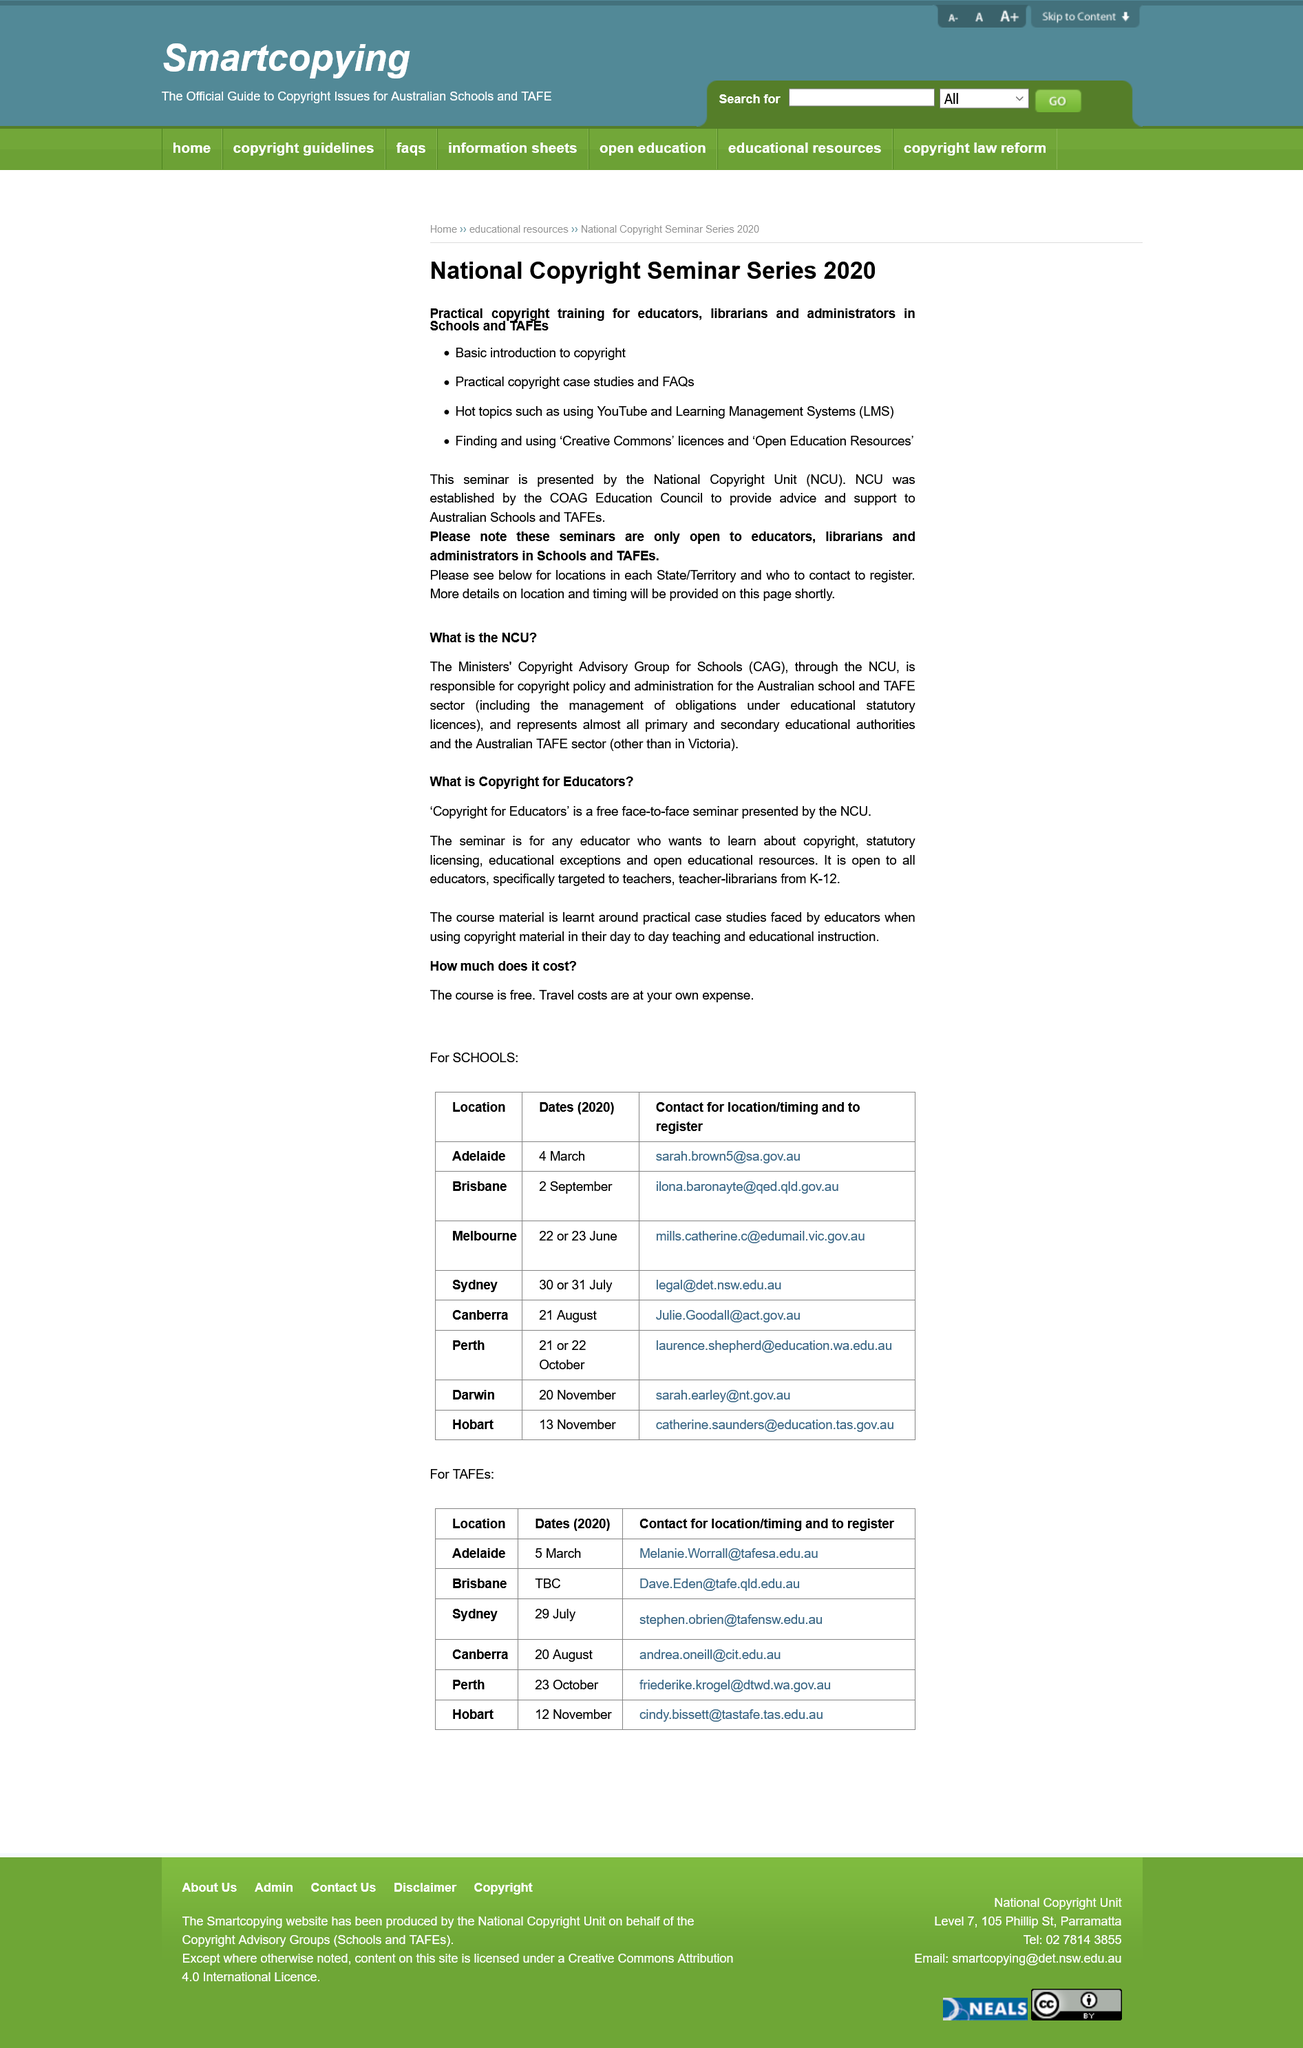Draw attention to some important aspects in this diagram. The National Copyright Unit (NCU) was established by the COAG Education Council. The seminar will cover 'Creative Commons' licenses. The National Copyright Seminar Series 2020 is designed for educators, librarians, and administrators in schools and TAFEs, with the aim of providing them with a comprehensive understanding of copyright law and its practical application in the educational setting. 